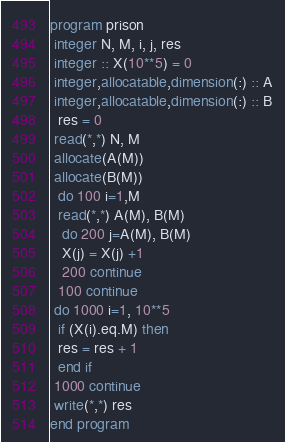<code> <loc_0><loc_0><loc_500><loc_500><_FORTRAN_>program prison
 integer N, M, i, j, res
 integer :: X(10**5) = 0
 integer,allocatable,dimension(:) :: A
 integer,allocatable,dimension(:) :: B
  res = 0
 read(*,*) N, M
 allocate(A(M))
 allocate(B(M))
  do 100 i=1,M
  read(*,*) A(M), B(M)
   do 200 j=A(M), B(M)
   X(j) = X(j) +1
   200 continue
  100 continue
 do 1000 i=1, 10**5
  if (X(i).eq.M) then
  res = res + 1
  end if
 1000 continue
 write(*,*) res
end program</code> 